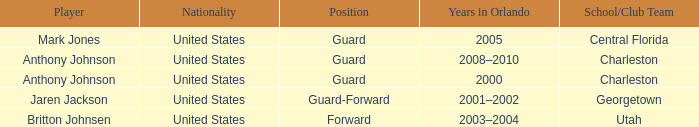Who was the Player that had the Position, guard-forward? Jaren Jackson. 